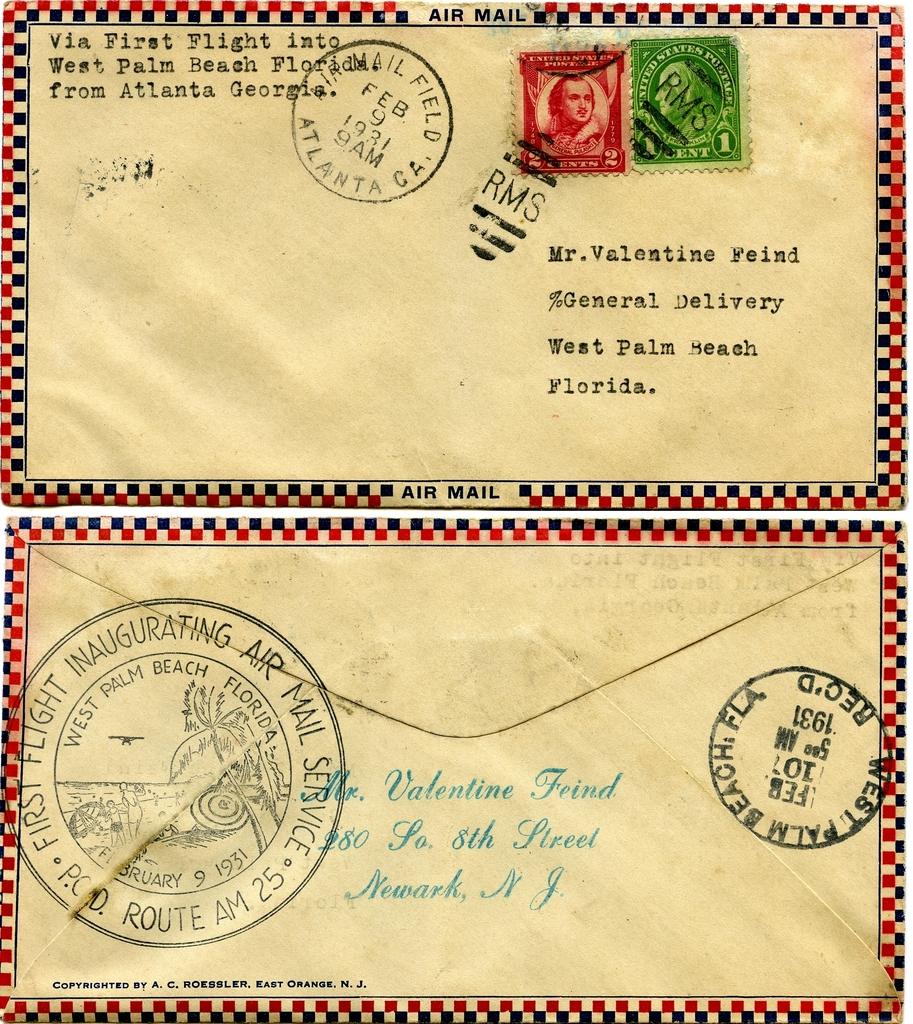Who is the letter addressed to?
Give a very brief answer. Mr. valentine feind. 